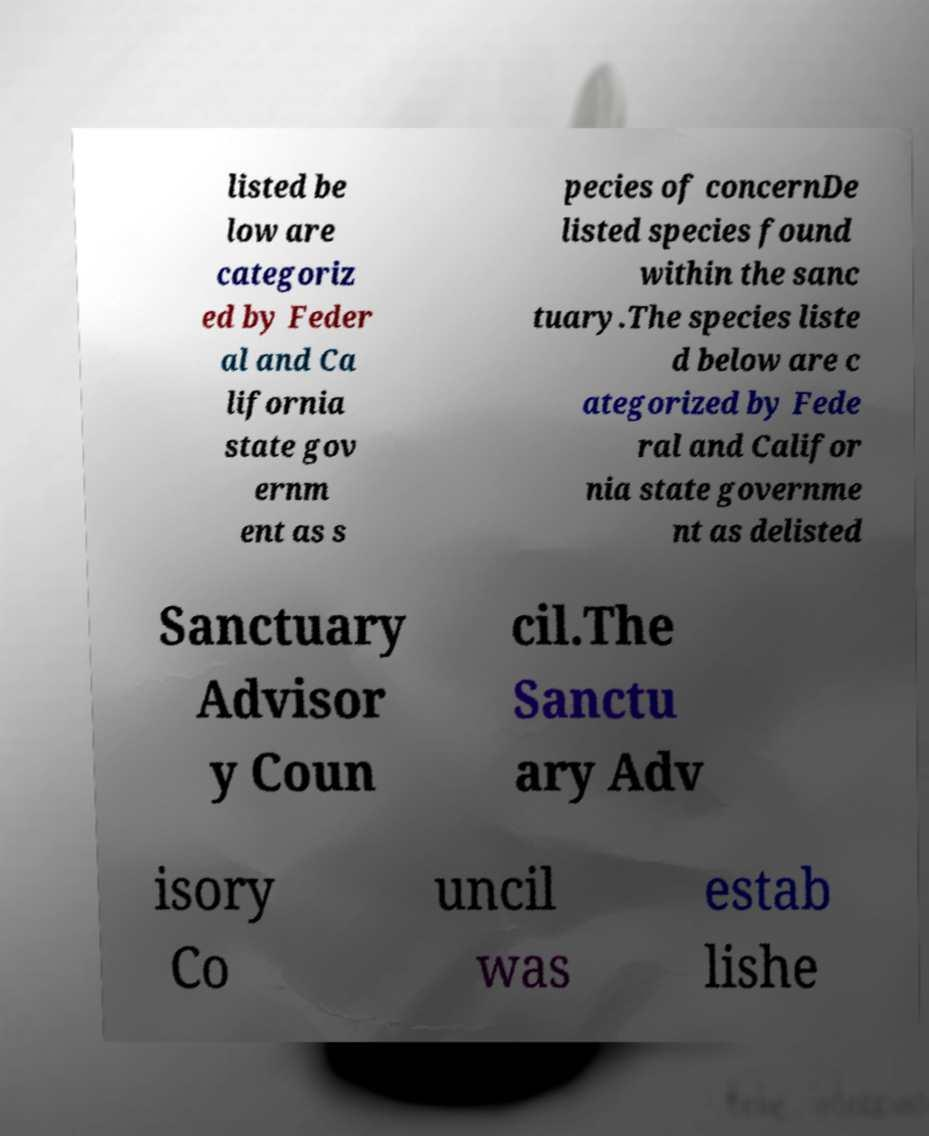Please identify and transcribe the text found in this image. listed be low are categoriz ed by Feder al and Ca lifornia state gov ernm ent as s pecies of concernDe listed species found within the sanc tuary.The species liste d below are c ategorized by Fede ral and Califor nia state governme nt as delisted Sanctuary Advisor y Coun cil.The Sanctu ary Adv isory Co uncil was estab lishe 